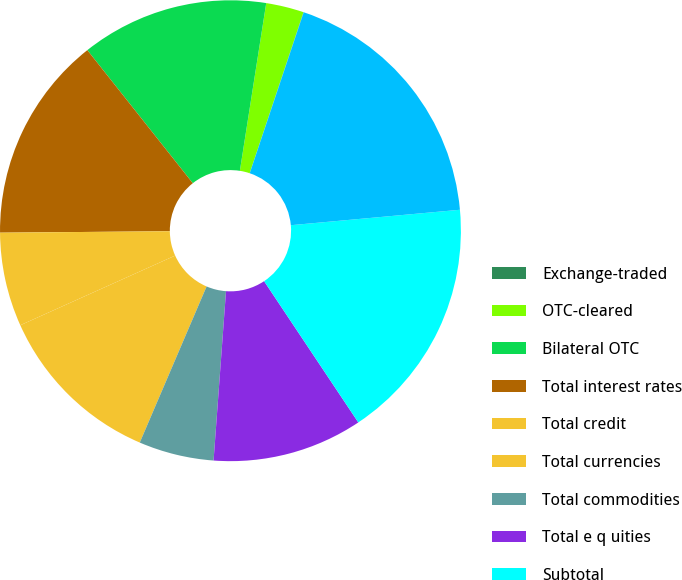Convert chart to OTSL. <chart><loc_0><loc_0><loc_500><loc_500><pie_chart><fcel>Exchange-traded<fcel>OTC-cleared<fcel>Bilateral OTC<fcel>Total interest rates<fcel>Total credit<fcel>Total currencies<fcel>Total commodities<fcel>Total e q uities<fcel>Subtotal<fcel>Total gross fair value<nl><fcel>0.02%<fcel>2.65%<fcel>13.15%<fcel>14.47%<fcel>6.59%<fcel>11.84%<fcel>5.27%<fcel>10.53%<fcel>17.09%<fcel>18.4%<nl></chart> 